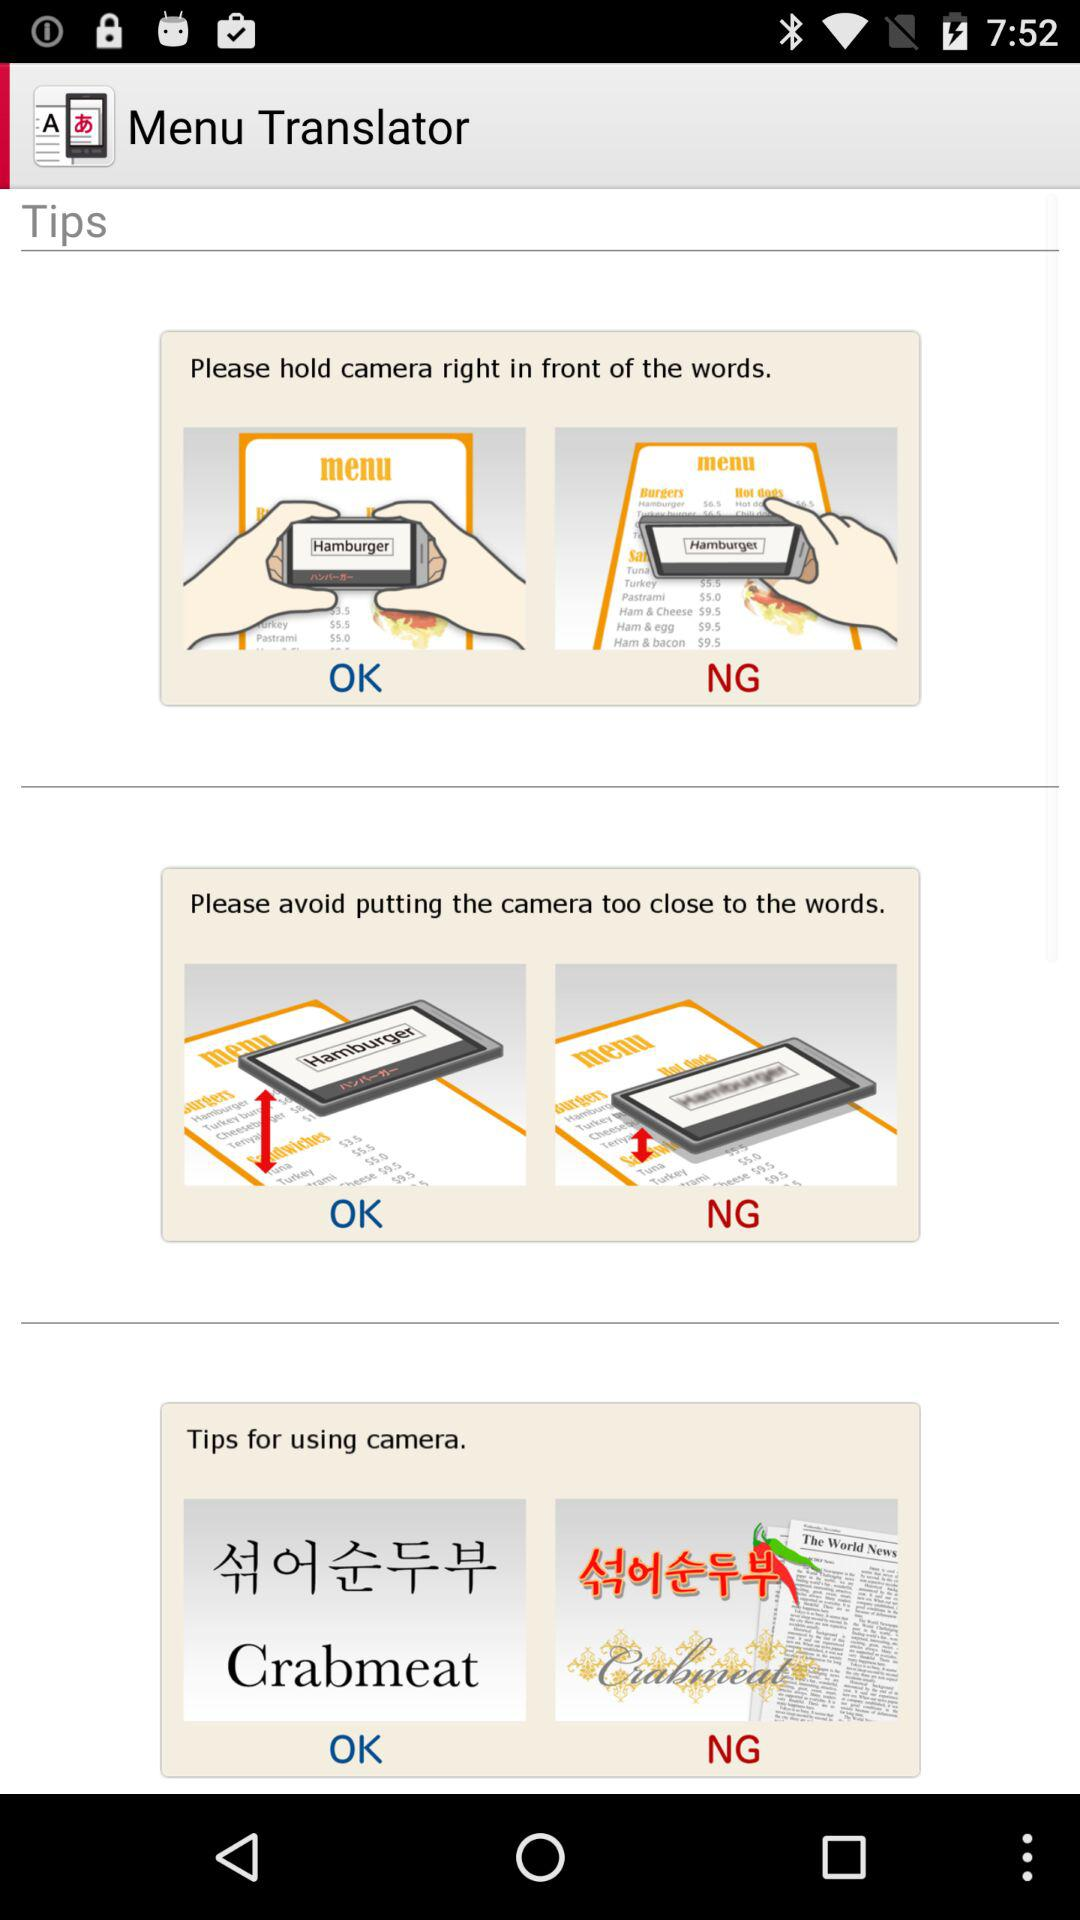What is the application name? The application name is "Menu Translator". 